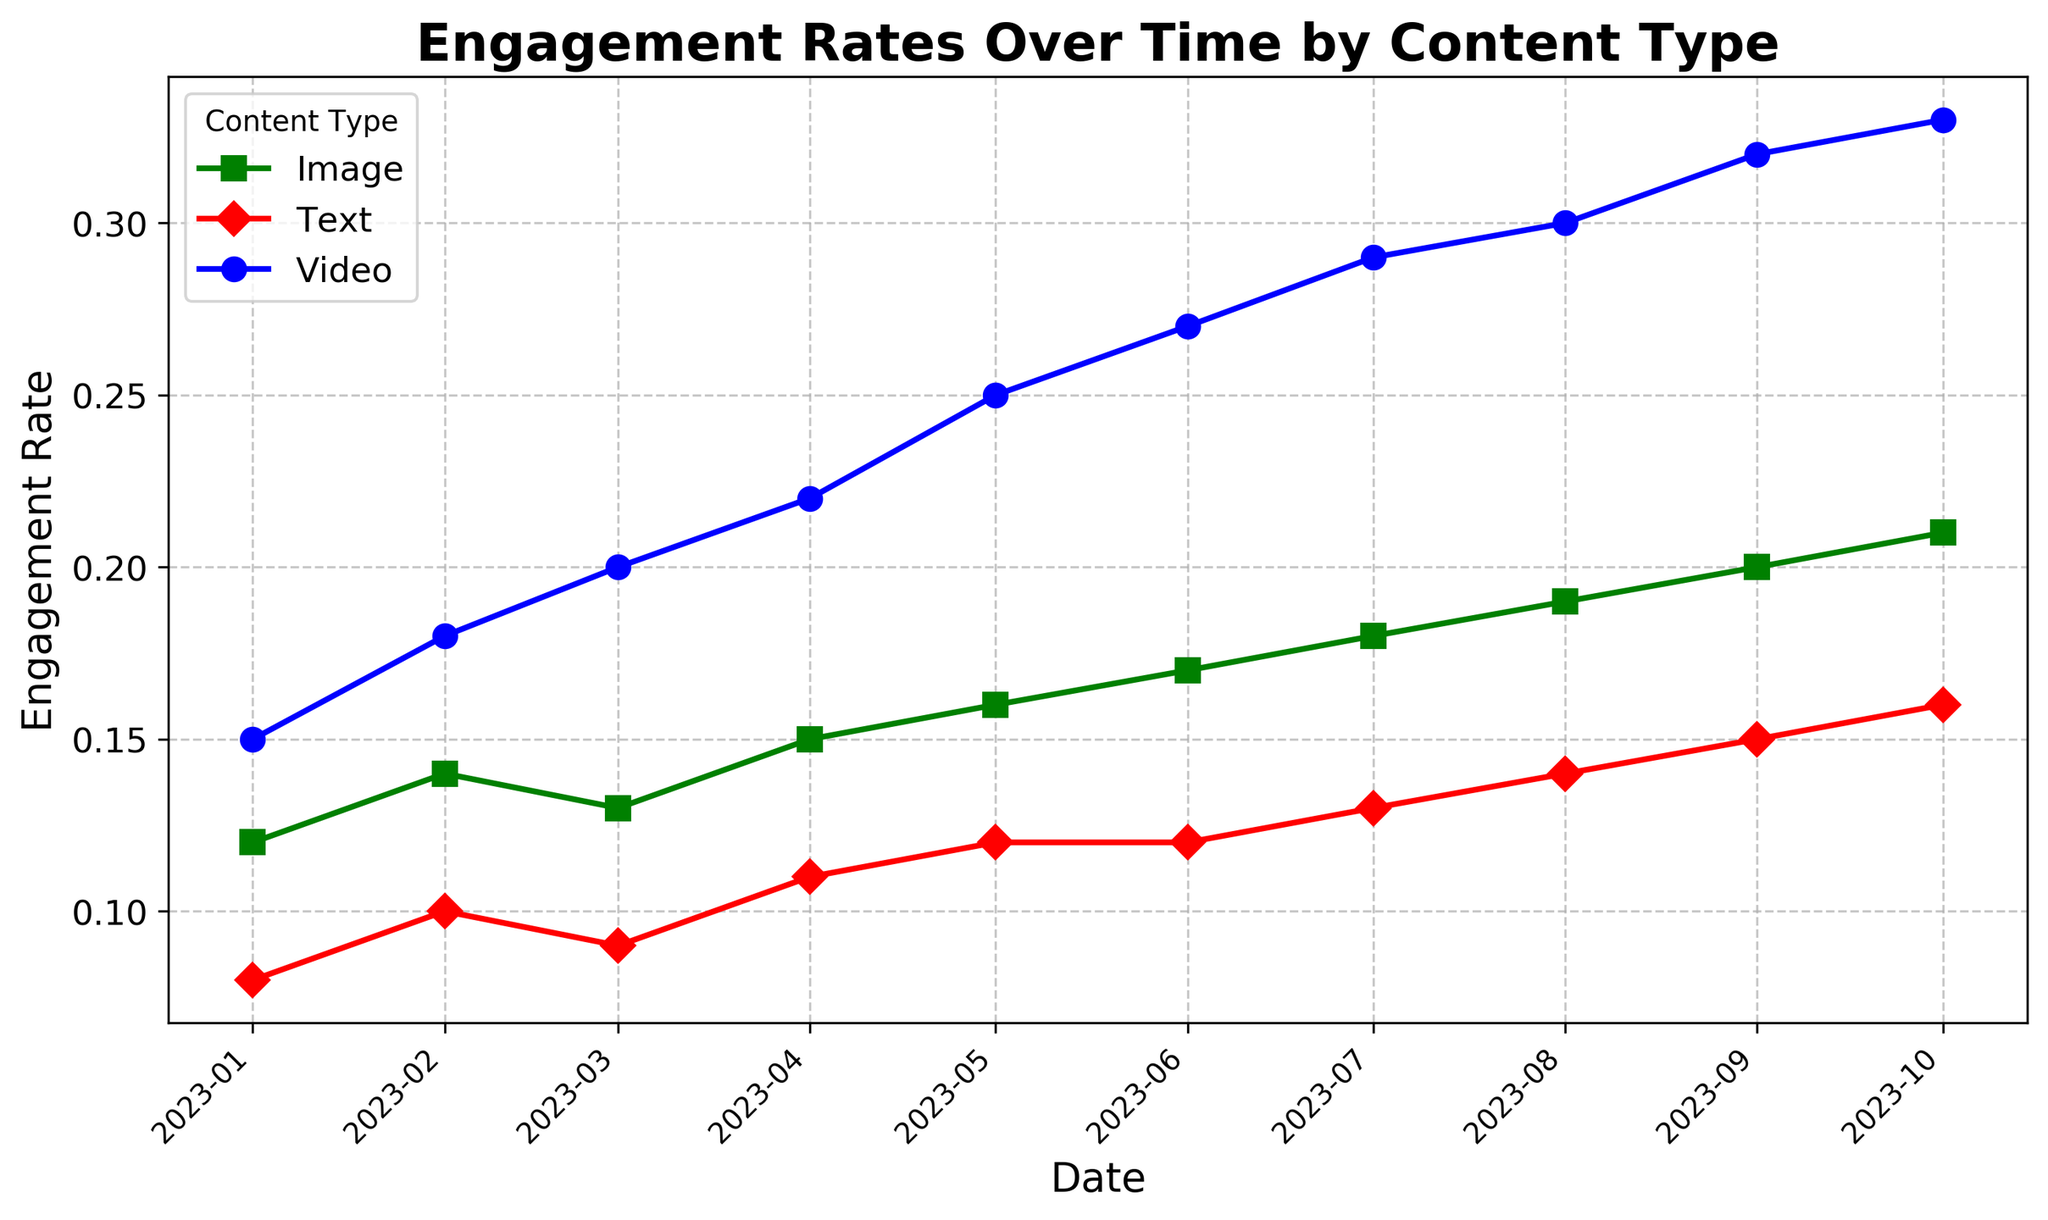What's the trend in engagement rates for Video content from January to October 2023? The engagement rate for Video content starts at 0.15 in January and consistently increases each month, reaching 0.33 in October.
Answer: Consistently increasing Which content type has the highest engagement rate in October 2023? By observing the engagement rates in October 2023, Video content has the highest engagement rate of 0.33.
Answer: Video By how much did the engagement rate for Text content change from January to October 2023? The engagement rate for Text content starts at 0.08 in January and rises to 0.16 in October. The change is equal to 0.16 - 0.08 = 0.08.
Answer: 0.08 Which month experienced the greatest increase in engagement rates for Image content? Comparing the engagement rates for Image content between consecutive months, the greatest increase is seen from August to September, going from 0.19 to 0.20, which is an increase of 0.01.
Answer: August to September What is the average engagement rate for Video content over the entire period? Adding the engagement rates for Video content from January to October and dividing by the number of months: (0.15 + 0.18 + 0.20 + 0.22 + 0.25 + 0.27 + 0.29 + 0.30 + 0.32 + 0.33) / 10 = 0.251.
Answer: 0.251 Did any content type experience a decrease in engagement rate at any point from January to October 2023? By reviewing the lines for Video, Image, and Text content, there are no decreases; all engagement rates either stay the same or increase month over month.
Answer: No Compare the engagement rates for Image and Text content in May 2023. Which was higher and by how much? In May 2023, the engagement rate for Image content is 0.16, and for Text content, it is 0.12. The difference is 0.16 - 0.12 = 0.04, making Image content higher by 0.04.
Answer: Image by 0.04 What's the overall trend for engagement rates of Text content throughout the year? The engagement rate for Text content shows a generally increasing trend from 0.08 in January to 0.16 in October, with some small fluctuations.
Answer: Generally increasing Which content type shows the least variability in engagement rates throughout the year? By observing the engagement rates for Video, Image, and Text content, Text content shows the least variability with a range from 0.08 to 0.16.
Answer: Text 